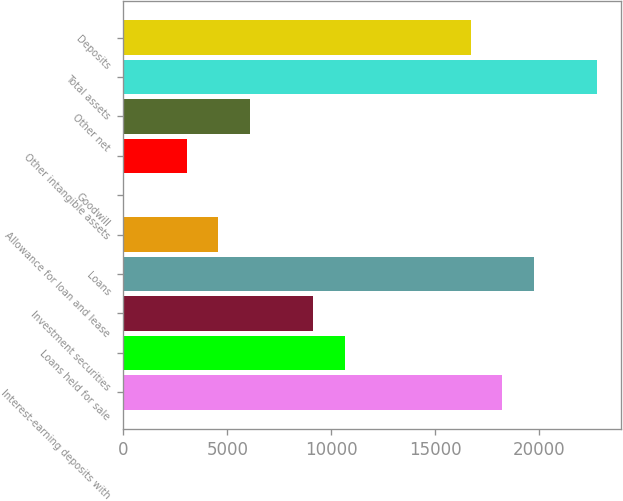Convert chart to OTSL. <chart><loc_0><loc_0><loc_500><loc_500><bar_chart><fcel>Interest-earning deposits with<fcel>Loans held for sale<fcel>Investment securities<fcel>Loans<fcel>Allowance for loan and lease<fcel>Goodwill<fcel>Other intangible assets<fcel>Other net<fcel>Total assets<fcel>Deposits<nl><fcel>18226.4<fcel>10632.9<fcel>9114.2<fcel>19745.1<fcel>4558.1<fcel>2<fcel>3039.4<fcel>6076.8<fcel>22782.5<fcel>16707.7<nl></chart> 